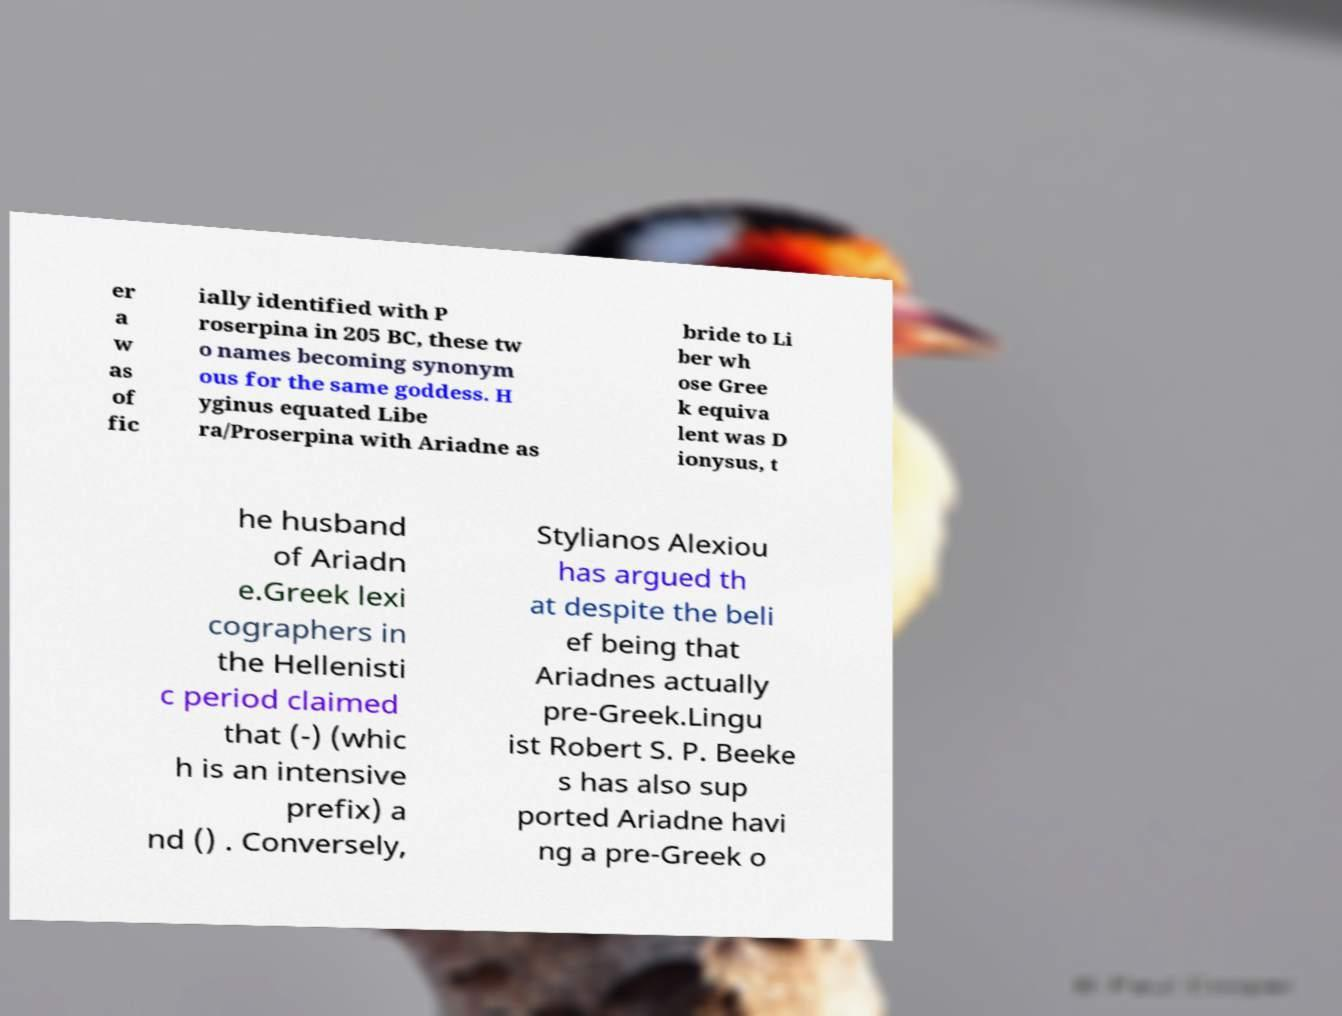Please identify and transcribe the text found in this image. er a w as of fic ially identified with P roserpina in 205 BC, these tw o names becoming synonym ous for the same goddess. H yginus equated Libe ra/Proserpina with Ariadne as bride to Li ber wh ose Gree k equiva lent was D ionysus, t he husband of Ariadn e.Greek lexi cographers in the Hellenisti c period claimed that (-) (whic h is an intensive prefix) a nd () . Conversely, Stylianos Alexiou has argued th at despite the beli ef being that Ariadnes actually pre-Greek.Lingu ist Robert S. P. Beeke s has also sup ported Ariadne havi ng a pre-Greek o 